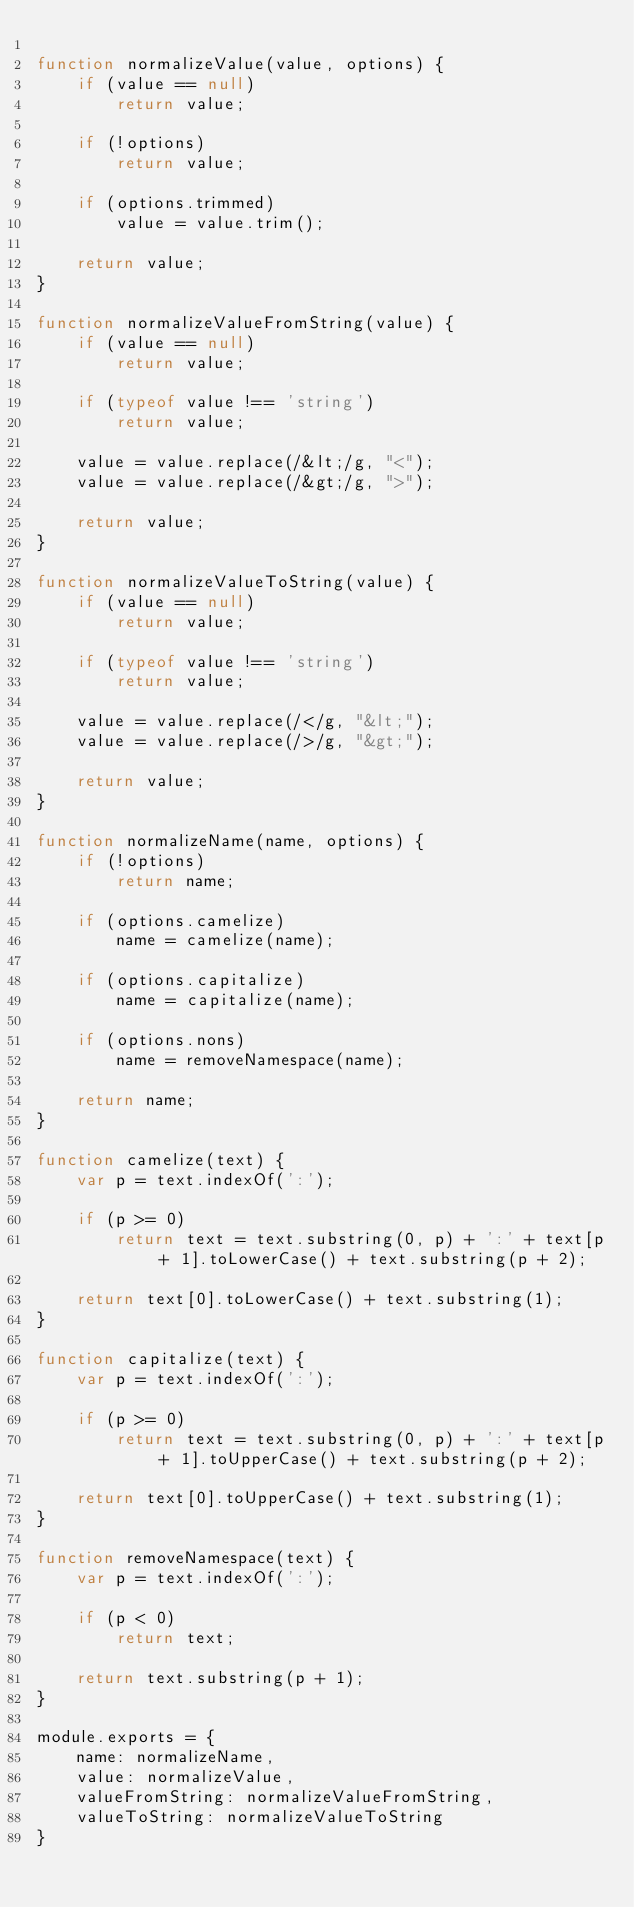<code> <loc_0><loc_0><loc_500><loc_500><_JavaScript_>
function normalizeValue(value, options) {
    if (value == null)
        return value;
        
    if (!options)
        return value;
    
    if (options.trimmed)
        value = value.trim();
    
    return value;
}

function normalizeValueFromString(value) {
    if (value == null)
        return value;
        
    if (typeof value !== 'string')
        return value;
        
    value = value.replace(/&lt;/g, "<");
    value = value.replace(/&gt;/g, ">");
    
    return value;
}

function normalizeValueToString(value) {
    if (value == null)
        return value;
        
    if (typeof value !== 'string')
        return value;
        
    value = value.replace(/</g, "&lt;");
    value = value.replace(/>/g, "&gt;");
    
    return value;
}

function normalizeName(name, options) {
    if (!options)
        return name;
    
    if (options.camelize)
        name = camelize(name);

    if (options.capitalize)
        name = capitalize(name);
    
    if (options.nons)
        name = removeNamespace(name);
    
    return name;
}

function camelize(text) {
    var p = text.indexOf(':');
    
    if (p >= 0)
        return text = text.substring(0, p) + ':' + text[p + 1].toLowerCase() + text.substring(p + 2);
    
    return text[0].toLowerCase() + text.substring(1);
}

function capitalize(text) {
    var p = text.indexOf(':');
    
    if (p >= 0)
        return text = text.substring(0, p) + ':' + text[p + 1].toUpperCase() + text.substring(p + 2);
    
    return text[0].toUpperCase() + text.substring(1);
}

function removeNamespace(text) {
    var p = text.indexOf(':');
    
    if (p < 0)
        return text;
    
    return text.substring(p + 1);
}

module.exports = {
    name: normalizeName,
    value: normalizeValue,
    valueFromString: normalizeValueFromString,
    valueToString: normalizeValueToString
}</code> 